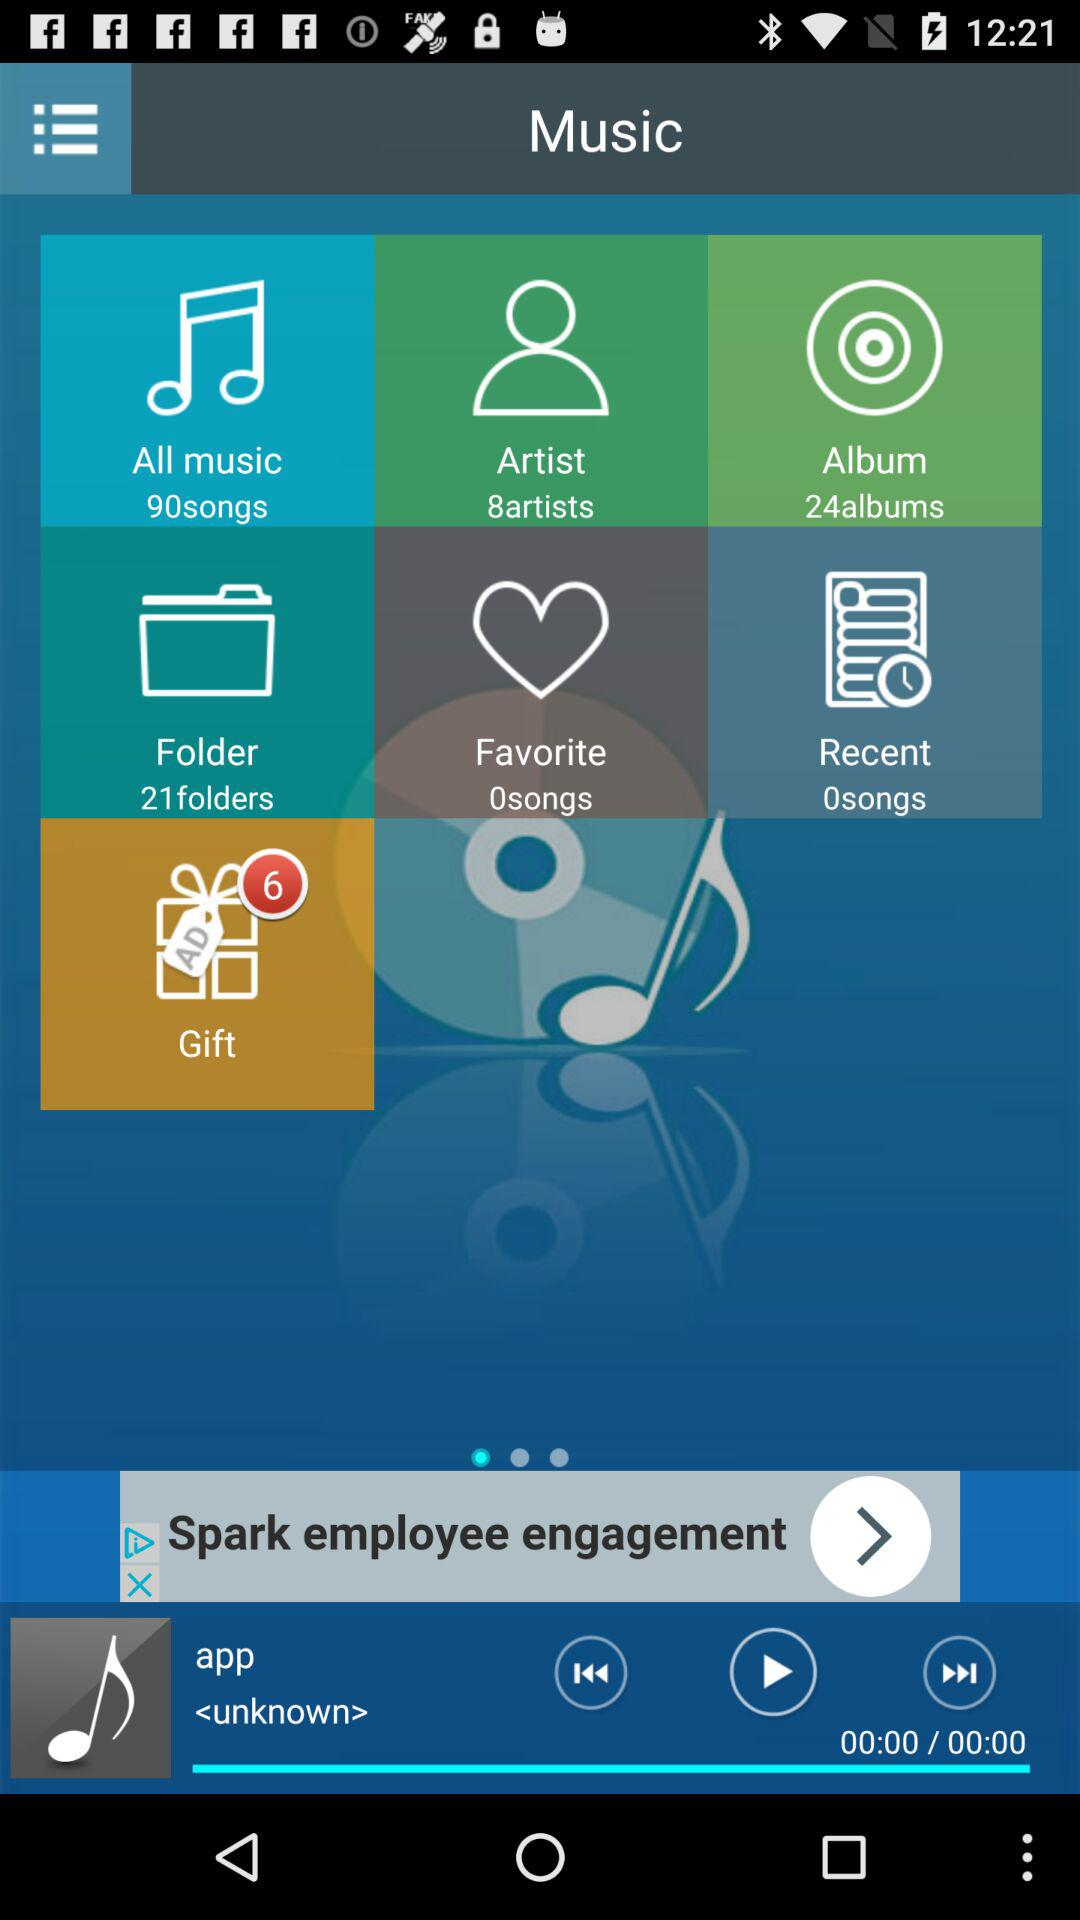Which song is currently playing? The song is "app". 